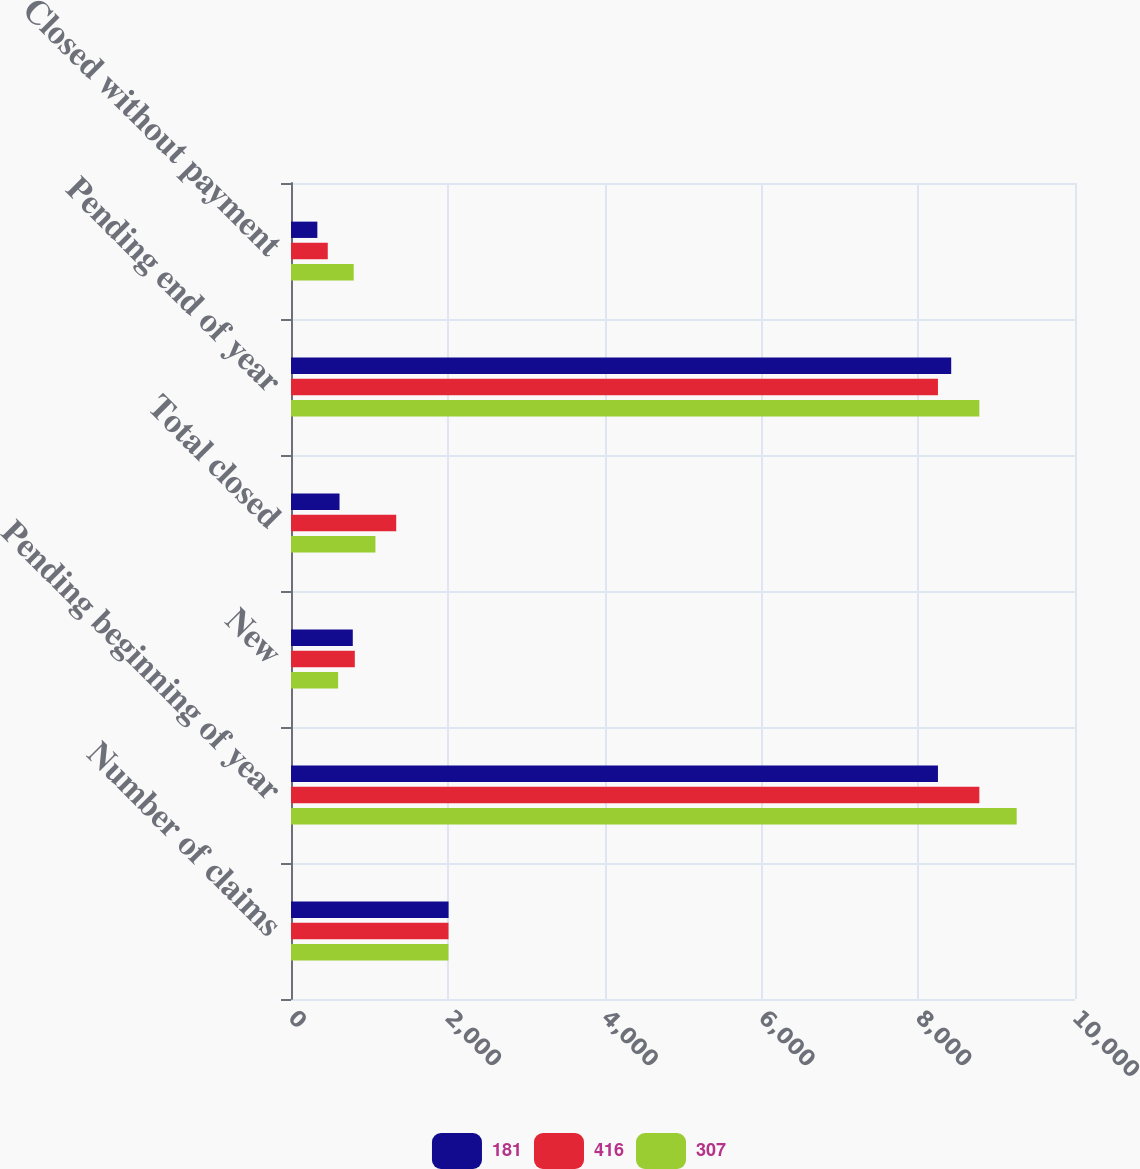Convert chart. <chart><loc_0><loc_0><loc_500><loc_500><stacked_bar_chart><ecel><fcel>Number of claims<fcel>Pending beginning of year<fcel>New<fcel>Total closed<fcel>Pending end of year<fcel>Closed without payment<nl><fcel>181<fcel>2010<fcel>8252<fcel>788<fcel>619<fcel>8421<fcel>336<nl><fcel>416<fcel>2009<fcel>8780<fcel>814<fcel>1342<fcel>8252<fcel>469<nl><fcel>307<fcel>2008<fcel>9256<fcel>601<fcel>1077<fcel>8780<fcel>800<nl></chart> 